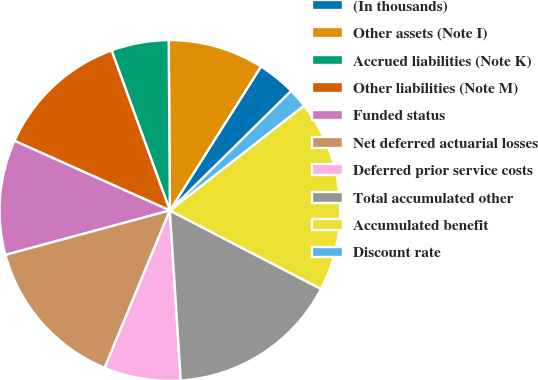Convert chart. <chart><loc_0><loc_0><loc_500><loc_500><pie_chart><fcel>(In thousands)<fcel>Other assets (Note I)<fcel>Accrued liabilities (Note K)<fcel>Other liabilities (Note M)<fcel>Funded status<fcel>Net deferred actuarial losses<fcel>Deferred prior service costs<fcel>Total accumulated other<fcel>Accumulated benefit<fcel>Discount rate<nl><fcel>3.64%<fcel>9.09%<fcel>5.45%<fcel>12.73%<fcel>10.91%<fcel>14.55%<fcel>7.27%<fcel>16.36%<fcel>18.18%<fcel>1.82%<nl></chart> 